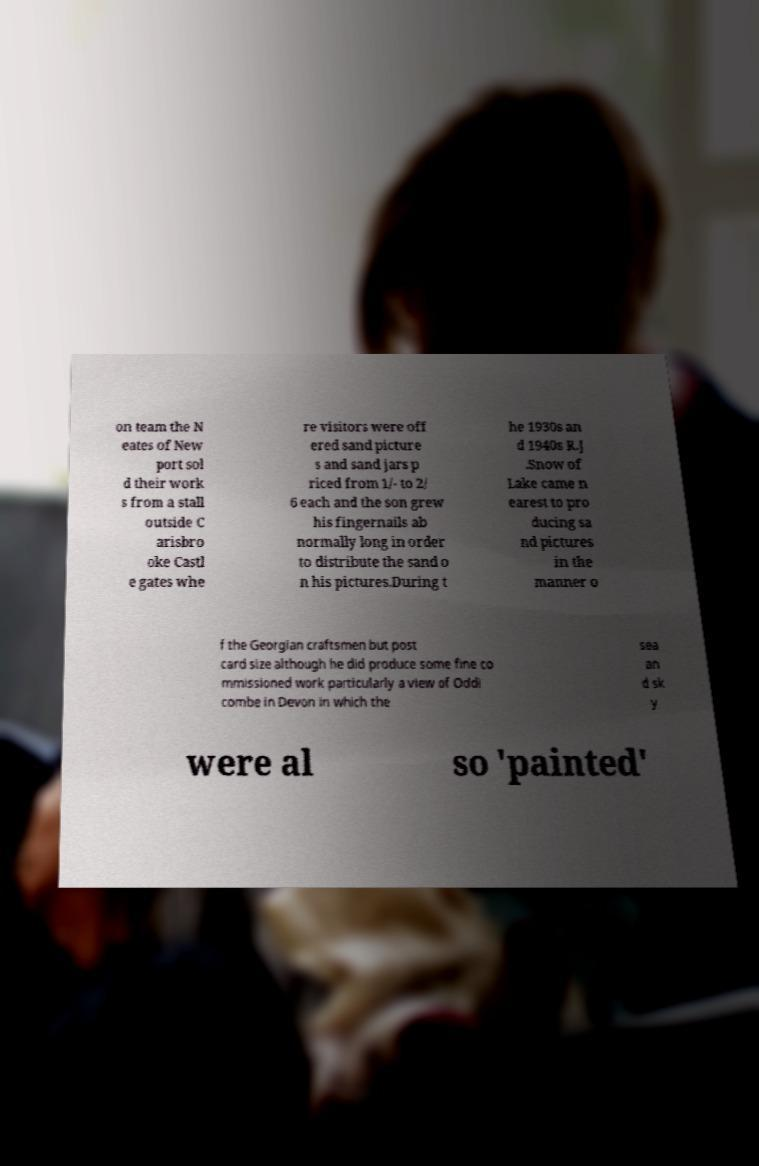Could you assist in decoding the text presented in this image and type it out clearly? on team the N eates of New port sol d their work s from a stall outside C arisbro oke Castl e gates whe re visitors were off ered sand picture s and sand jars p riced from 1/- to 2/ 6 each and the son grew his fingernails ab normally long in order to distribute the sand o n his pictures.During t he 1930s an d 1940s R.J .Snow of Lake came n earest to pro ducing sa nd pictures in the manner o f the Georgian craftsmen but post card size although he did produce some fine co mmissioned work particularly a view of Oddi combe in Devon in which the sea an d sk y were al so 'painted' 